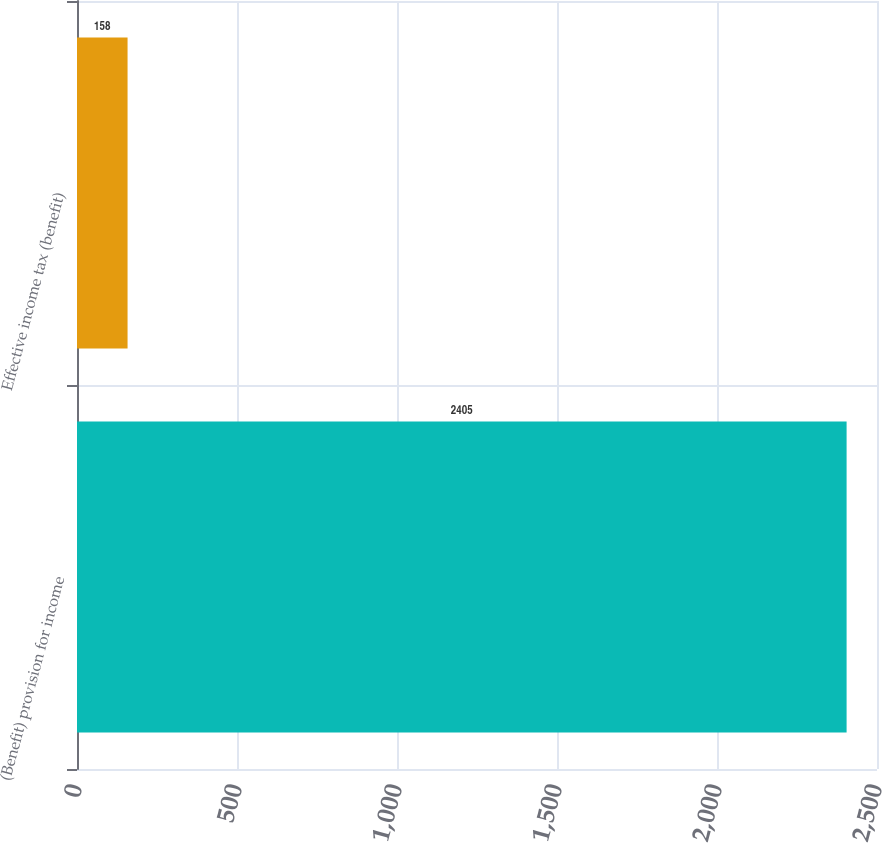Convert chart to OTSL. <chart><loc_0><loc_0><loc_500><loc_500><bar_chart><fcel>(Benefit) provision for income<fcel>Effective income tax (benefit)<nl><fcel>2405<fcel>158<nl></chart> 